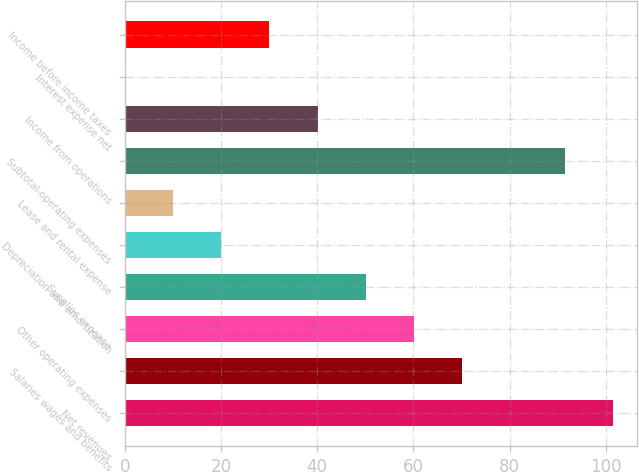Convert chart. <chart><loc_0><loc_0><loc_500><loc_500><bar_chart><fcel>Net revenues<fcel>Salaries wages and benefits<fcel>Other operating expenses<fcel>Supplies expense<fcel>Depreciation and amortization<fcel>Lease and rental expense<fcel>Subtotal-operating expenses<fcel>Income from operations<fcel>Interest expense net<fcel>Income before income taxes<nl><fcel>101.39<fcel>70.03<fcel>60.04<fcel>50.05<fcel>20.08<fcel>10.09<fcel>91.4<fcel>40.06<fcel>0.1<fcel>30.07<nl></chart> 